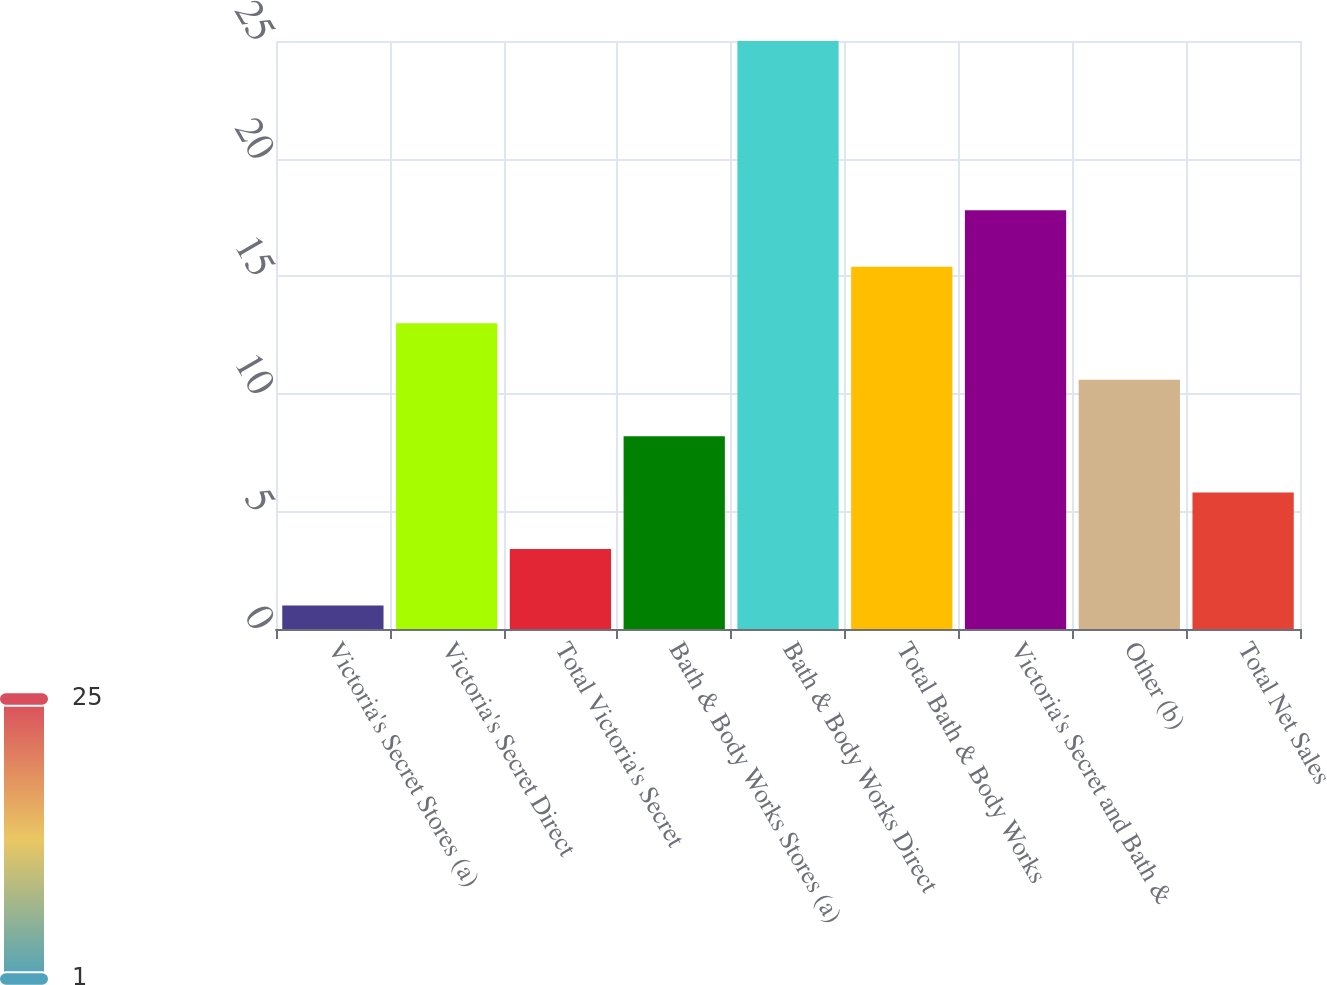<chart> <loc_0><loc_0><loc_500><loc_500><bar_chart><fcel>Victoria's Secret Stores (a)<fcel>Victoria's Secret Direct<fcel>Total Victoria's Secret<fcel>Bath & Body Works Stores (a)<fcel>Bath & Body Works Direct<fcel>Total Bath & Body Works<fcel>Victoria's Secret and Bath &<fcel>Other (b)<fcel>Total Net Sales<nl><fcel>1<fcel>13<fcel>3.4<fcel>8.2<fcel>25<fcel>15.4<fcel>17.8<fcel>10.6<fcel>5.8<nl></chart> 